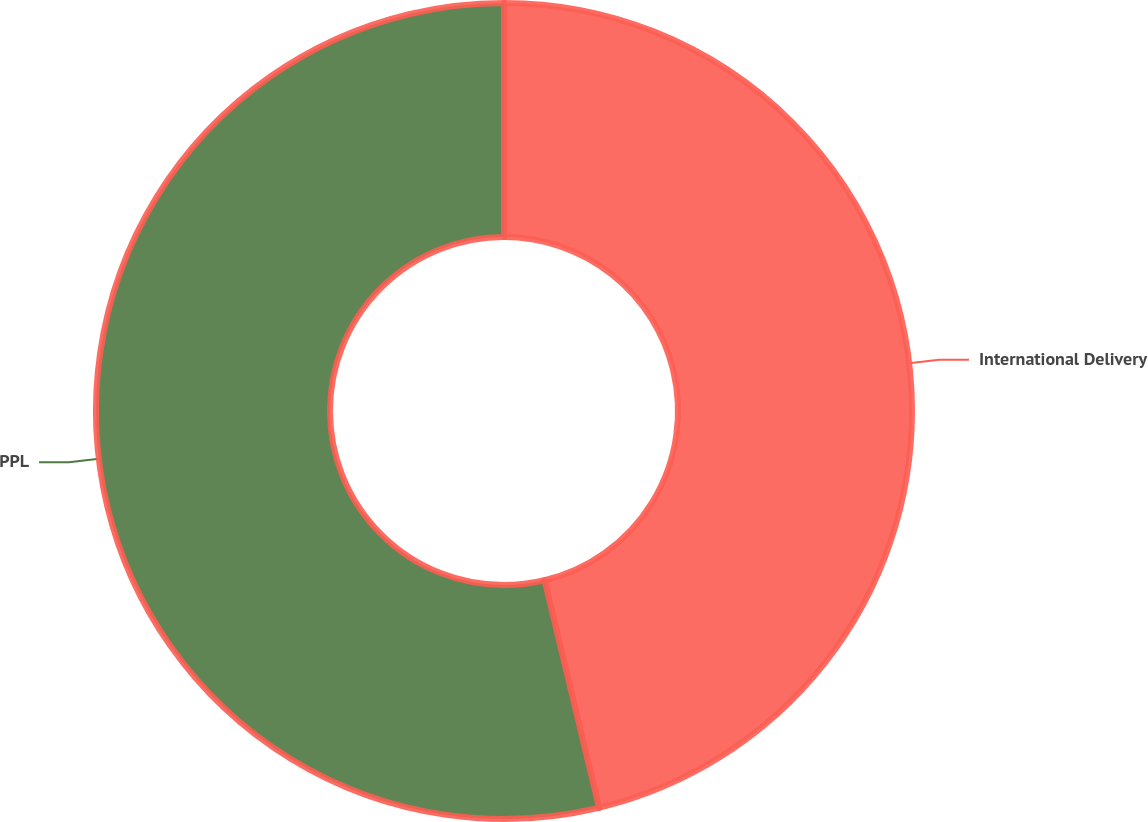<chart> <loc_0><loc_0><loc_500><loc_500><pie_chart><fcel>International Delivery<fcel>PPL<nl><fcel>46.26%<fcel>53.74%<nl></chart> 